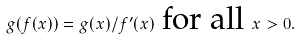<formula> <loc_0><loc_0><loc_500><loc_500>g ( f ( x ) ) = g ( x ) / f ^ { \prime } ( x ) \text { for all } x > 0 .</formula> 